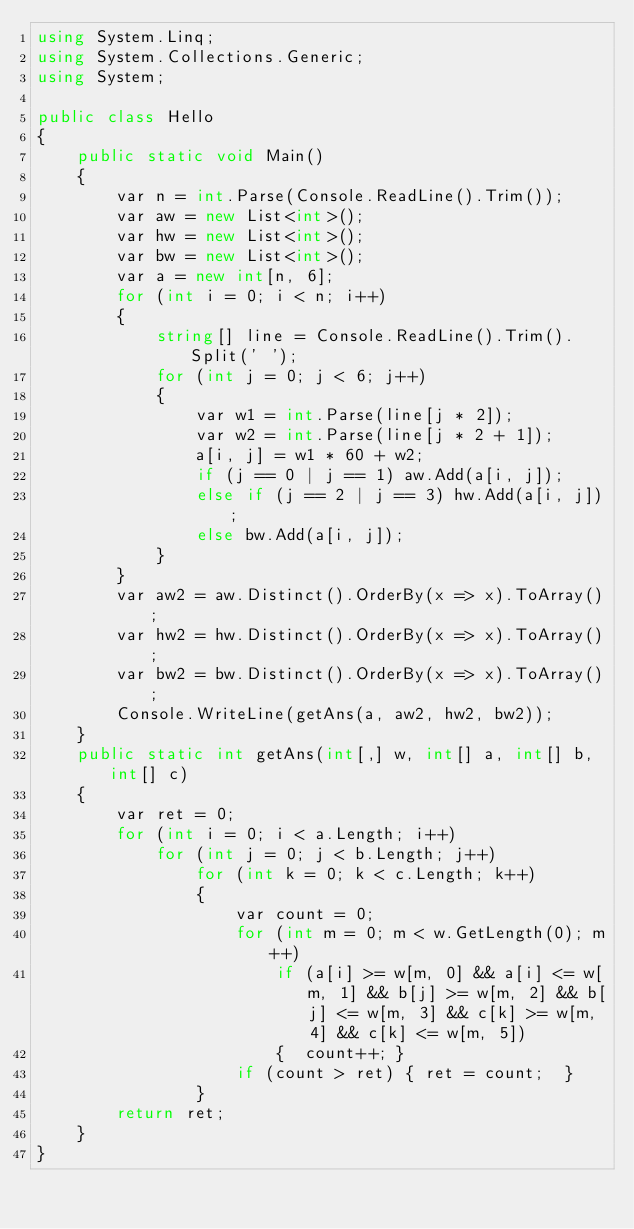<code> <loc_0><loc_0><loc_500><loc_500><_C#_>using System.Linq;
using System.Collections.Generic;
using System;

public class Hello
{
    public static void Main()
    {
        var n = int.Parse(Console.ReadLine().Trim());
        var aw = new List<int>();
        var hw = new List<int>();
        var bw = new List<int>();
        var a = new int[n, 6];
        for (int i = 0; i < n; i++)
        {
            string[] line = Console.ReadLine().Trim().Split(' ');
            for (int j = 0; j < 6; j++)
            {
                var w1 = int.Parse(line[j * 2]);
                var w2 = int.Parse(line[j * 2 + 1]);
                a[i, j] = w1 * 60 + w2;
                if (j == 0 | j == 1) aw.Add(a[i, j]);
                else if (j == 2 | j == 3) hw.Add(a[i, j]);
                else bw.Add(a[i, j]);
            }
        }
        var aw2 = aw.Distinct().OrderBy(x => x).ToArray();
        var hw2 = hw.Distinct().OrderBy(x => x).ToArray();
        var bw2 = bw.Distinct().OrderBy(x => x).ToArray();
        Console.WriteLine(getAns(a, aw2, hw2, bw2));
    }
    public static int getAns(int[,] w, int[] a, int[] b, int[] c)
    {
        var ret = 0;
        for (int i = 0; i < a.Length; i++)
            for (int j = 0; j < b.Length; j++)
                for (int k = 0; k < c.Length; k++)
                {
                    var count = 0;
                    for (int m = 0; m < w.GetLength(0); m++)
                        if (a[i] >= w[m, 0] && a[i] <= w[m, 1] && b[j] >= w[m, 2] && b[j] <= w[m, 3] && c[k] >= w[m, 4] && c[k] <= w[m, 5])
                        {  count++; }
                    if (count > ret) { ret = count;  }
                }
        return ret;
    }
}


</code> 